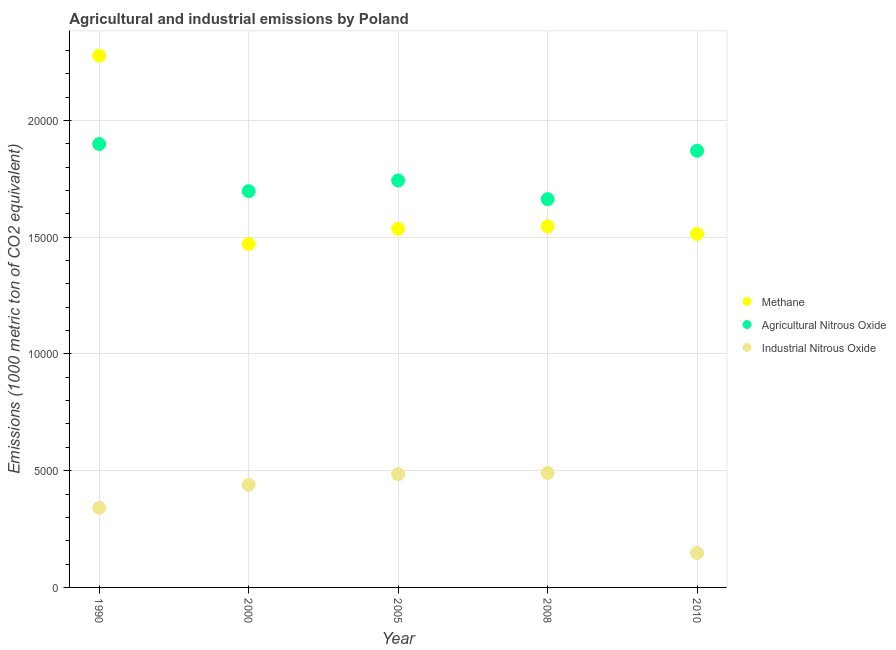How many different coloured dotlines are there?
Keep it short and to the point. 3. Is the number of dotlines equal to the number of legend labels?
Offer a very short reply. Yes. What is the amount of methane emissions in 2010?
Offer a very short reply. 1.51e+04. Across all years, what is the maximum amount of industrial nitrous oxide emissions?
Provide a succinct answer. 4902.7. Across all years, what is the minimum amount of industrial nitrous oxide emissions?
Keep it short and to the point. 1474.1. In which year was the amount of industrial nitrous oxide emissions maximum?
Provide a short and direct response. 2008. In which year was the amount of industrial nitrous oxide emissions minimum?
Provide a succinct answer. 2010. What is the total amount of methane emissions in the graph?
Make the answer very short. 8.34e+04. What is the difference between the amount of agricultural nitrous oxide emissions in 1990 and that in 2005?
Provide a succinct answer. 1561.1. What is the difference between the amount of methane emissions in 2010 and the amount of agricultural nitrous oxide emissions in 2000?
Your response must be concise. -1833.1. What is the average amount of methane emissions per year?
Make the answer very short. 1.67e+04. In the year 2010, what is the difference between the amount of industrial nitrous oxide emissions and amount of agricultural nitrous oxide emissions?
Offer a very short reply. -1.72e+04. In how many years, is the amount of agricultural nitrous oxide emissions greater than 9000 metric ton?
Ensure brevity in your answer.  5. What is the ratio of the amount of agricultural nitrous oxide emissions in 2000 to that in 2005?
Give a very brief answer. 0.97. What is the difference between the highest and the second highest amount of methane emissions?
Offer a very short reply. 7311.1. What is the difference between the highest and the lowest amount of industrial nitrous oxide emissions?
Make the answer very short. 3428.6. Is the sum of the amount of agricultural nitrous oxide emissions in 1990 and 2005 greater than the maximum amount of methane emissions across all years?
Give a very brief answer. Yes. Is it the case that in every year, the sum of the amount of methane emissions and amount of agricultural nitrous oxide emissions is greater than the amount of industrial nitrous oxide emissions?
Provide a succinct answer. Yes. Does the amount of industrial nitrous oxide emissions monotonically increase over the years?
Keep it short and to the point. No. Is the amount of agricultural nitrous oxide emissions strictly less than the amount of industrial nitrous oxide emissions over the years?
Give a very brief answer. No. How many dotlines are there?
Provide a short and direct response. 3. Does the graph contain grids?
Provide a succinct answer. Yes. What is the title of the graph?
Make the answer very short. Agricultural and industrial emissions by Poland. Does "Unpaid family workers" appear as one of the legend labels in the graph?
Give a very brief answer. No. What is the label or title of the X-axis?
Offer a terse response. Year. What is the label or title of the Y-axis?
Make the answer very short. Emissions (1000 metric ton of CO2 equivalent). What is the Emissions (1000 metric ton of CO2 equivalent) of Methane in 1990?
Provide a succinct answer. 2.28e+04. What is the Emissions (1000 metric ton of CO2 equivalent) in Agricultural Nitrous Oxide in 1990?
Offer a very short reply. 1.90e+04. What is the Emissions (1000 metric ton of CO2 equivalent) in Industrial Nitrous Oxide in 1990?
Offer a very short reply. 3408.2. What is the Emissions (1000 metric ton of CO2 equivalent) of Methane in 2000?
Keep it short and to the point. 1.47e+04. What is the Emissions (1000 metric ton of CO2 equivalent) of Agricultural Nitrous Oxide in 2000?
Your answer should be compact. 1.70e+04. What is the Emissions (1000 metric ton of CO2 equivalent) of Industrial Nitrous Oxide in 2000?
Provide a short and direct response. 4392.5. What is the Emissions (1000 metric ton of CO2 equivalent) in Methane in 2005?
Offer a terse response. 1.54e+04. What is the Emissions (1000 metric ton of CO2 equivalent) in Agricultural Nitrous Oxide in 2005?
Keep it short and to the point. 1.74e+04. What is the Emissions (1000 metric ton of CO2 equivalent) in Industrial Nitrous Oxide in 2005?
Your response must be concise. 4849. What is the Emissions (1000 metric ton of CO2 equivalent) in Methane in 2008?
Provide a succinct answer. 1.55e+04. What is the Emissions (1000 metric ton of CO2 equivalent) of Agricultural Nitrous Oxide in 2008?
Your answer should be very brief. 1.66e+04. What is the Emissions (1000 metric ton of CO2 equivalent) of Industrial Nitrous Oxide in 2008?
Provide a succinct answer. 4902.7. What is the Emissions (1000 metric ton of CO2 equivalent) of Methane in 2010?
Provide a short and direct response. 1.51e+04. What is the Emissions (1000 metric ton of CO2 equivalent) of Agricultural Nitrous Oxide in 2010?
Offer a terse response. 1.87e+04. What is the Emissions (1000 metric ton of CO2 equivalent) in Industrial Nitrous Oxide in 2010?
Ensure brevity in your answer.  1474.1. Across all years, what is the maximum Emissions (1000 metric ton of CO2 equivalent) in Methane?
Make the answer very short. 2.28e+04. Across all years, what is the maximum Emissions (1000 metric ton of CO2 equivalent) of Agricultural Nitrous Oxide?
Provide a succinct answer. 1.90e+04. Across all years, what is the maximum Emissions (1000 metric ton of CO2 equivalent) in Industrial Nitrous Oxide?
Make the answer very short. 4902.7. Across all years, what is the minimum Emissions (1000 metric ton of CO2 equivalent) of Methane?
Your answer should be compact. 1.47e+04. Across all years, what is the minimum Emissions (1000 metric ton of CO2 equivalent) in Agricultural Nitrous Oxide?
Your response must be concise. 1.66e+04. Across all years, what is the minimum Emissions (1000 metric ton of CO2 equivalent) of Industrial Nitrous Oxide?
Your answer should be compact. 1474.1. What is the total Emissions (1000 metric ton of CO2 equivalent) in Methane in the graph?
Ensure brevity in your answer.  8.34e+04. What is the total Emissions (1000 metric ton of CO2 equivalent) of Agricultural Nitrous Oxide in the graph?
Offer a very short reply. 8.87e+04. What is the total Emissions (1000 metric ton of CO2 equivalent) of Industrial Nitrous Oxide in the graph?
Provide a short and direct response. 1.90e+04. What is the difference between the Emissions (1000 metric ton of CO2 equivalent) of Methane in 1990 and that in 2000?
Provide a succinct answer. 8065. What is the difference between the Emissions (1000 metric ton of CO2 equivalent) of Agricultural Nitrous Oxide in 1990 and that in 2000?
Give a very brief answer. 2018.2. What is the difference between the Emissions (1000 metric ton of CO2 equivalent) of Industrial Nitrous Oxide in 1990 and that in 2000?
Your answer should be compact. -984.3. What is the difference between the Emissions (1000 metric ton of CO2 equivalent) in Methane in 1990 and that in 2005?
Ensure brevity in your answer.  7413.7. What is the difference between the Emissions (1000 metric ton of CO2 equivalent) in Agricultural Nitrous Oxide in 1990 and that in 2005?
Keep it short and to the point. 1561.1. What is the difference between the Emissions (1000 metric ton of CO2 equivalent) in Industrial Nitrous Oxide in 1990 and that in 2005?
Provide a succinct answer. -1440.8. What is the difference between the Emissions (1000 metric ton of CO2 equivalent) of Methane in 1990 and that in 2008?
Offer a terse response. 7311.1. What is the difference between the Emissions (1000 metric ton of CO2 equivalent) of Agricultural Nitrous Oxide in 1990 and that in 2008?
Your answer should be very brief. 2360.6. What is the difference between the Emissions (1000 metric ton of CO2 equivalent) of Industrial Nitrous Oxide in 1990 and that in 2008?
Offer a very short reply. -1494.5. What is the difference between the Emissions (1000 metric ton of CO2 equivalent) of Methane in 1990 and that in 2010?
Provide a succinct answer. 7634.1. What is the difference between the Emissions (1000 metric ton of CO2 equivalent) of Agricultural Nitrous Oxide in 1990 and that in 2010?
Your response must be concise. 287.1. What is the difference between the Emissions (1000 metric ton of CO2 equivalent) of Industrial Nitrous Oxide in 1990 and that in 2010?
Offer a very short reply. 1934.1. What is the difference between the Emissions (1000 metric ton of CO2 equivalent) in Methane in 2000 and that in 2005?
Offer a terse response. -651.3. What is the difference between the Emissions (1000 metric ton of CO2 equivalent) of Agricultural Nitrous Oxide in 2000 and that in 2005?
Provide a succinct answer. -457.1. What is the difference between the Emissions (1000 metric ton of CO2 equivalent) in Industrial Nitrous Oxide in 2000 and that in 2005?
Offer a very short reply. -456.5. What is the difference between the Emissions (1000 metric ton of CO2 equivalent) of Methane in 2000 and that in 2008?
Provide a succinct answer. -753.9. What is the difference between the Emissions (1000 metric ton of CO2 equivalent) in Agricultural Nitrous Oxide in 2000 and that in 2008?
Provide a succinct answer. 342.4. What is the difference between the Emissions (1000 metric ton of CO2 equivalent) of Industrial Nitrous Oxide in 2000 and that in 2008?
Offer a very short reply. -510.2. What is the difference between the Emissions (1000 metric ton of CO2 equivalent) of Methane in 2000 and that in 2010?
Give a very brief answer. -430.9. What is the difference between the Emissions (1000 metric ton of CO2 equivalent) in Agricultural Nitrous Oxide in 2000 and that in 2010?
Your response must be concise. -1731.1. What is the difference between the Emissions (1000 metric ton of CO2 equivalent) of Industrial Nitrous Oxide in 2000 and that in 2010?
Make the answer very short. 2918.4. What is the difference between the Emissions (1000 metric ton of CO2 equivalent) in Methane in 2005 and that in 2008?
Keep it short and to the point. -102.6. What is the difference between the Emissions (1000 metric ton of CO2 equivalent) in Agricultural Nitrous Oxide in 2005 and that in 2008?
Your answer should be very brief. 799.5. What is the difference between the Emissions (1000 metric ton of CO2 equivalent) of Industrial Nitrous Oxide in 2005 and that in 2008?
Ensure brevity in your answer.  -53.7. What is the difference between the Emissions (1000 metric ton of CO2 equivalent) in Methane in 2005 and that in 2010?
Give a very brief answer. 220.4. What is the difference between the Emissions (1000 metric ton of CO2 equivalent) in Agricultural Nitrous Oxide in 2005 and that in 2010?
Your answer should be very brief. -1274. What is the difference between the Emissions (1000 metric ton of CO2 equivalent) of Industrial Nitrous Oxide in 2005 and that in 2010?
Offer a terse response. 3374.9. What is the difference between the Emissions (1000 metric ton of CO2 equivalent) in Methane in 2008 and that in 2010?
Give a very brief answer. 323. What is the difference between the Emissions (1000 metric ton of CO2 equivalent) in Agricultural Nitrous Oxide in 2008 and that in 2010?
Offer a terse response. -2073.5. What is the difference between the Emissions (1000 metric ton of CO2 equivalent) of Industrial Nitrous Oxide in 2008 and that in 2010?
Offer a terse response. 3428.6. What is the difference between the Emissions (1000 metric ton of CO2 equivalent) in Methane in 1990 and the Emissions (1000 metric ton of CO2 equivalent) in Agricultural Nitrous Oxide in 2000?
Offer a terse response. 5801. What is the difference between the Emissions (1000 metric ton of CO2 equivalent) in Methane in 1990 and the Emissions (1000 metric ton of CO2 equivalent) in Industrial Nitrous Oxide in 2000?
Your response must be concise. 1.84e+04. What is the difference between the Emissions (1000 metric ton of CO2 equivalent) in Agricultural Nitrous Oxide in 1990 and the Emissions (1000 metric ton of CO2 equivalent) in Industrial Nitrous Oxide in 2000?
Offer a very short reply. 1.46e+04. What is the difference between the Emissions (1000 metric ton of CO2 equivalent) of Methane in 1990 and the Emissions (1000 metric ton of CO2 equivalent) of Agricultural Nitrous Oxide in 2005?
Offer a very short reply. 5343.9. What is the difference between the Emissions (1000 metric ton of CO2 equivalent) of Methane in 1990 and the Emissions (1000 metric ton of CO2 equivalent) of Industrial Nitrous Oxide in 2005?
Your answer should be compact. 1.79e+04. What is the difference between the Emissions (1000 metric ton of CO2 equivalent) of Agricultural Nitrous Oxide in 1990 and the Emissions (1000 metric ton of CO2 equivalent) of Industrial Nitrous Oxide in 2005?
Keep it short and to the point. 1.41e+04. What is the difference between the Emissions (1000 metric ton of CO2 equivalent) in Methane in 1990 and the Emissions (1000 metric ton of CO2 equivalent) in Agricultural Nitrous Oxide in 2008?
Your answer should be compact. 6143.4. What is the difference between the Emissions (1000 metric ton of CO2 equivalent) of Methane in 1990 and the Emissions (1000 metric ton of CO2 equivalent) of Industrial Nitrous Oxide in 2008?
Ensure brevity in your answer.  1.79e+04. What is the difference between the Emissions (1000 metric ton of CO2 equivalent) of Agricultural Nitrous Oxide in 1990 and the Emissions (1000 metric ton of CO2 equivalent) of Industrial Nitrous Oxide in 2008?
Keep it short and to the point. 1.41e+04. What is the difference between the Emissions (1000 metric ton of CO2 equivalent) of Methane in 1990 and the Emissions (1000 metric ton of CO2 equivalent) of Agricultural Nitrous Oxide in 2010?
Provide a succinct answer. 4069.9. What is the difference between the Emissions (1000 metric ton of CO2 equivalent) of Methane in 1990 and the Emissions (1000 metric ton of CO2 equivalent) of Industrial Nitrous Oxide in 2010?
Provide a short and direct response. 2.13e+04. What is the difference between the Emissions (1000 metric ton of CO2 equivalent) in Agricultural Nitrous Oxide in 1990 and the Emissions (1000 metric ton of CO2 equivalent) in Industrial Nitrous Oxide in 2010?
Offer a very short reply. 1.75e+04. What is the difference between the Emissions (1000 metric ton of CO2 equivalent) in Methane in 2000 and the Emissions (1000 metric ton of CO2 equivalent) in Agricultural Nitrous Oxide in 2005?
Offer a very short reply. -2721.1. What is the difference between the Emissions (1000 metric ton of CO2 equivalent) in Methane in 2000 and the Emissions (1000 metric ton of CO2 equivalent) in Industrial Nitrous Oxide in 2005?
Give a very brief answer. 9859.5. What is the difference between the Emissions (1000 metric ton of CO2 equivalent) in Agricultural Nitrous Oxide in 2000 and the Emissions (1000 metric ton of CO2 equivalent) in Industrial Nitrous Oxide in 2005?
Provide a succinct answer. 1.21e+04. What is the difference between the Emissions (1000 metric ton of CO2 equivalent) of Methane in 2000 and the Emissions (1000 metric ton of CO2 equivalent) of Agricultural Nitrous Oxide in 2008?
Ensure brevity in your answer.  -1921.6. What is the difference between the Emissions (1000 metric ton of CO2 equivalent) of Methane in 2000 and the Emissions (1000 metric ton of CO2 equivalent) of Industrial Nitrous Oxide in 2008?
Provide a short and direct response. 9805.8. What is the difference between the Emissions (1000 metric ton of CO2 equivalent) of Agricultural Nitrous Oxide in 2000 and the Emissions (1000 metric ton of CO2 equivalent) of Industrial Nitrous Oxide in 2008?
Your answer should be very brief. 1.21e+04. What is the difference between the Emissions (1000 metric ton of CO2 equivalent) of Methane in 2000 and the Emissions (1000 metric ton of CO2 equivalent) of Agricultural Nitrous Oxide in 2010?
Provide a short and direct response. -3995.1. What is the difference between the Emissions (1000 metric ton of CO2 equivalent) in Methane in 2000 and the Emissions (1000 metric ton of CO2 equivalent) in Industrial Nitrous Oxide in 2010?
Ensure brevity in your answer.  1.32e+04. What is the difference between the Emissions (1000 metric ton of CO2 equivalent) of Agricultural Nitrous Oxide in 2000 and the Emissions (1000 metric ton of CO2 equivalent) of Industrial Nitrous Oxide in 2010?
Provide a succinct answer. 1.55e+04. What is the difference between the Emissions (1000 metric ton of CO2 equivalent) of Methane in 2005 and the Emissions (1000 metric ton of CO2 equivalent) of Agricultural Nitrous Oxide in 2008?
Keep it short and to the point. -1270.3. What is the difference between the Emissions (1000 metric ton of CO2 equivalent) in Methane in 2005 and the Emissions (1000 metric ton of CO2 equivalent) in Industrial Nitrous Oxide in 2008?
Your answer should be very brief. 1.05e+04. What is the difference between the Emissions (1000 metric ton of CO2 equivalent) of Agricultural Nitrous Oxide in 2005 and the Emissions (1000 metric ton of CO2 equivalent) of Industrial Nitrous Oxide in 2008?
Your answer should be very brief. 1.25e+04. What is the difference between the Emissions (1000 metric ton of CO2 equivalent) of Methane in 2005 and the Emissions (1000 metric ton of CO2 equivalent) of Agricultural Nitrous Oxide in 2010?
Your answer should be compact. -3343.8. What is the difference between the Emissions (1000 metric ton of CO2 equivalent) of Methane in 2005 and the Emissions (1000 metric ton of CO2 equivalent) of Industrial Nitrous Oxide in 2010?
Provide a short and direct response. 1.39e+04. What is the difference between the Emissions (1000 metric ton of CO2 equivalent) in Agricultural Nitrous Oxide in 2005 and the Emissions (1000 metric ton of CO2 equivalent) in Industrial Nitrous Oxide in 2010?
Make the answer very short. 1.60e+04. What is the difference between the Emissions (1000 metric ton of CO2 equivalent) in Methane in 2008 and the Emissions (1000 metric ton of CO2 equivalent) in Agricultural Nitrous Oxide in 2010?
Your answer should be very brief. -3241.2. What is the difference between the Emissions (1000 metric ton of CO2 equivalent) of Methane in 2008 and the Emissions (1000 metric ton of CO2 equivalent) of Industrial Nitrous Oxide in 2010?
Your answer should be compact. 1.40e+04. What is the difference between the Emissions (1000 metric ton of CO2 equivalent) in Agricultural Nitrous Oxide in 2008 and the Emissions (1000 metric ton of CO2 equivalent) in Industrial Nitrous Oxide in 2010?
Give a very brief answer. 1.52e+04. What is the average Emissions (1000 metric ton of CO2 equivalent) in Methane per year?
Offer a very short reply. 1.67e+04. What is the average Emissions (1000 metric ton of CO2 equivalent) in Agricultural Nitrous Oxide per year?
Ensure brevity in your answer.  1.77e+04. What is the average Emissions (1000 metric ton of CO2 equivalent) in Industrial Nitrous Oxide per year?
Offer a very short reply. 3805.3. In the year 1990, what is the difference between the Emissions (1000 metric ton of CO2 equivalent) in Methane and Emissions (1000 metric ton of CO2 equivalent) in Agricultural Nitrous Oxide?
Your answer should be compact. 3782.8. In the year 1990, what is the difference between the Emissions (1000 metric ton of CO2 equivalent) in Methane and Emissions (1000 metric ton of CO2 equivalent) in Industrial Nitrous Oxide?
Keep it short and to the point. 1.94e+04. In the year 1990, what is the difference between the Emissions (1000 metric ton of CO2 equivalent) in Agricultural Nitrous Oxide and Emissions (1000 metric ton of CO2 equivalent) in Industrial Nitrous Oxide?
Give a very brief answer. 1.56e+04. In the year 2000, what is the difference between the Emissions (1000 metric ton of CO2 equivalent) in Methane and Emissions (1000 metric ton of CO2 equivalent) in Agricultural Nitrous Oxide?
Your answer should be compact. -2264. In the year 2000, what is the difference between the Emissions (1000 metric ton of CO2 equivalent) in Methane and Emissions (1000 metric ton of CO2 equivalent) in Industrial Nitrous Oxide?
Offer a very short reply. 1.03e+04. In the year 2000, what is the difference between the Emissions (1000 metric ton of CO2 equivalent) of Agricultural Nitrous Oxide and Emissions (1000 metric ton of CO2 equivalent) of Industrial Nitrous Oxide?
Provide a succinct answer. 1.26e+04. In the year 2005, what is the difference between the Emissions (1000 metric ton of CO2 equivalent) of Methane and Emissions (1000 metric ton of CO2 equivalent) of Agricultural Nitrous Oxide?
Your answer should be compact. -2069.8. In the year 2005, what is the difference between the Emissions (1000 metric ton of CO2 equivalent) in Methane and Emissions (1000 metric ton of CO2 equivalent) in Industrial Nitrous Oxide?
Keep it short and to the point. 1.05e+04. In the year 2005, what is the difference between the Emissions (1000 metric ton of CO2 equivalent) of Agricultural Nitrous Oxide and Emissions (1000 metric ton of CO2 equivalent) of Industrial Nitrous Oxide?
Make the answer very short. 1.26e+04. In the year 2008, what is the difference between the Emissions (1000 metric ton of CO2 equivalent) in Methane and Emissions (1000 metric ton of CO2 equivalent) in Agricultural Nitrous Oxide?
Offer a terse response. -1167.7. In the year 2008, what is the difference between the Emissions (1000 metric ton of CO2 equivalent) in Methane and Emissions (1000 metric ton of CO2 equivalent) in Industrial Nitrous Oxide?
Your answer should be very brief. 1.06e+04. In the year 2008, what is the difference between the Emissions (1000 metric ton of CO2 equivalent) in Agricultural Nitrous Oxide and Emissions (1000 metric ton of CO2 equivalent) in Industrial Nitrous Oxide?
Ensure brevity in your answer.  1.17e+04. In the year 2010, what is the difference between the Emissions (1000 metric ton of CO2 equivalent) of Methane and Emissions (1000 metric ton of CO2 equivalent) of Agricultural Nitrous Oxide?
Your answer should be very brief. -3564.2. In the year 2010, what is the difference between the Emissions (1000 metric ton of CO2 equivalent) in Methane and Emissions (1000 metric ton of CO2 equivalent) in Industrial Nitrous Oxide?
Your answer should be compact. 1.37e+04. In the year 2010, what is the difference between the Emissions (1000 metric ton of CO2 equivalent) in Agricultural Nitrous Oxide and Emissions (1000 metric ton of CO2 equivalent) in Industrial Nitrous Oxide?
Provide a succinct answer. 1.72e+04. What is the ratio of the Emissions (1000 metric ton of CO2 equivalent) of Methane in 1990 to that in 2000?
Offer a very short reply. 1.55. What is the ratio of the Emissions (1000 metric ton of CO2 equivalent) in Agricultural Nitrous Oxide in 1990 to that in 2000?
Offer a very short reply. 1.12. What is the ratio of the Emissions (1000 metric ton of CO2 equivalent) of Industrial Nitrous Oxide in 1990 to that in 2000?
Provide a succinct answer. 0.78. What is the ratio of the Emissions (1000 metric ton of CO2 equivalent) in Methane in 1990 to that in 2005?
Your answer should be compact. 1.48. What is the ratio of the Emissions (1000 metric ton of CO2 equivalent) of Agricultural Nitrous Oxide in 1990 to that in 2005?
Ensure brevity in your answer.  1.09. What is the ratio of the Emissions (1000 metric ton of CO2 equivalent) of Industrial Nitrous Oxide in 1990 to that in 2005?
Offer a terse response. 0.7. What is the ratio of the Emissions (1000 metric ton of CO2 equivalent) in Methane in 1990 to that in 2008?
Provide a short and direct response. 1.47. What is the ratio of the Emissions (1000 metric ton of CO2 equivalent) in Agricultural Nitrous Oxide in 1990 to that in 2008?
Your response must be concise. 1.14. What is the ratio of the Emissions (1000 metric ton of CO2 equivalent) of Industrial Nitrous Oxide in 1990 to that in 2008?
Provide a short and direct response. 0.7. What is the ratio of the Emissions (1000 metric ton of CO2 equivalent) in Methane in 1990 to that in 2010?
Your answer should be very brief. 1.5. What is the ratio of the Emissions (1000 metric ton of CO2 equivalent) in Agricultural Nitrous Oxide in 1990 to that in 2010?
Your answer should be very brief. 1.02. What is the ratio of the Emissions (1000 metric ton of CO2 equivalent) of Industrial Nitrous Oxide in 1990 to that in 2010?
Your response must be concise. 2.31. What is the ratio of the Emissions (1000 metric ton of CO2 equivalent) of Methane in 2000 to that in 2005?
Provide a succinct answer. 0.96. What is the ratio of the Emissions (1000 metric ton of CO2 equivalent) in Agricultural Nitrous Oxide in 2000 to that in 2005?
Your response must be concise. 0.97. What is the ratio of the Emissions (1000 metric ton of CO2 equivalent) of Industrial Nitrous Oxide in 2000 to that in 2005?
Give a very brief answer. 0.91. What is the ratio of the Emissions (1000 metric ton of CO2 equivalent) of Methane in 2000 to that in 2008?
Make the answer very short. 0.95. What is the ratio of the Emissions (1000 metric ton of CO2 equivalent) of Agricultural Nitrous Oxide in 2000 to that in 2008?
Offer a terse response. 1.02. What is the ratio of the Emissions (1000 metric ton of CO2 equivalent) in Industrial Nitrous Oxide in 2000 to that in 2008?
Make the answer very short. 0.9. What is the ratio of the Emissions (1000 metric ton of CO2 equivalent) in Methane in 2000 to that in 2010?
Your answer should be very brief. 0.97. What is the ratio of the Emissions (1000 metric ton of CO2 equivalent) in Agricultural Nitrous Oxide in 2000 to that in 2010?
Offer a very short reply. 0.91. What is the ratio of the Emissions (1000 metric ton of CO2 equivalent) of Industrial Nitrous Oxide in 2000 to that in 2010?
Your response must be concise. 2.98. What is the ratio of the Emissions (1000 metric ton of CO2 equivalent) in Methane in 2005 to that in 2008?
Offer a terse response. 0.99. What is the ratio of the Emissions (1000 metric ton of CO2 equivalent) of Agricultural Nitrous Oxide in 2005 to that in 2008?
Ensure brevity in your answer.  1.05. What is the ratio of the Emissions (1000 metric ton of CO2 equivalent) in Methane in 2005 to that in 2010?
Provide a succinct answer. 1.01. What is the ratio of the Emissions (1000 metric ton of CO2 equivalent) in Agricultural Nitrous Oxide in 2005 to that in 2010?
Your answer should be very brief. 0.93. What is the ratio of the Emissions (1000 metric ton of CO2 equivalent) of Industrial Nitrous Oxide in 2005 to that in 2010?
Your response must be concise. 3.29. What is the ratio of the Emissions (1000 metric ton of CO2 equivalent) in Methane in 2008 to that in 2010?
Keep it short and to the point. 1.02. What is the ratio of the Emissions (1000 metric ton of CO2 equivalent) of Agricultural Nitrous Oxide in 2008 to that in 2010?
Provide a succinct answer. 0.89. What is the ratio of the Emissions (1000 metric ton of CO2 equivalent) in Industrial Nitrous Oxide in 2008 to that in 2010?
Provide a succinct answer. 3.33. What is the difference between the highest and the second highest Emissions (1000 metric ton of CO2 equivalent) of Methane?
Provide a short and direct response. 7311.1. What is the difference between the highest and the second highest Emissions (1000 metric ton of CO2 equivalent) in Agricultural Nitrous Oxide?
Ensure brevity in your answer.  287.1. What is the difference between the highest and the second highest Emissions (1000 metric ton of CO2 equivalent) in Industrial Nitrous Oxide?
Your response must be concise. 53.7. What is the difference between the highest and the lowest Emissions (1000 metric ton of CO2 equivalent) of Methane?
Your response must be concise. 8065. What is the difference between the highest and the lowest Emissions (1000 metric ton of CO2 equivalent) of Agricultural Nitrous Oxide?
Your answer should be compact. 2360.6. What is the difference between the highest and the lowest Emissions (1000 metric ton of CO2 equivalent) in Industrial Nitrous Oxide?
Provide a succinct answer. 3428.6. 